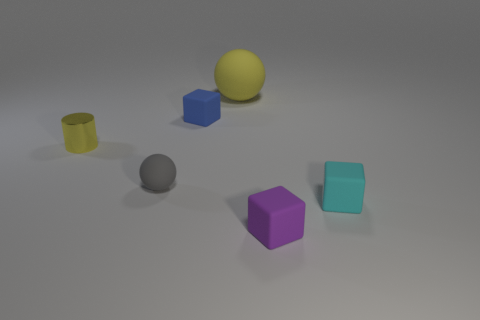What number of brown objects are either tiny cubes or big balls?
Offer a terse response. 0. There is a block on the right side of the matte object that is in front of the small cyan thing; what size is it?
Your answer should be compact. Small. Do the tiny rubber sphere and the small rubber block behind the tiny cylinder have the same color?
Make the answer very short. No. How many other things are there of the same material as the blue thing?
Ensure brevity in your answer.  4. What is the shape of the tiny gray object that is made of the same material as the big object?
Ensure brevity in your answer.  Sphere. Is there anything else that is the same color as the tiny metallic object?
Your answer should be compact. Yes. There is another shiny thing that is the same color as the big thing; what is its size?
Offer a terse response. Small. Is the number of small cyan blocks on the left side of the big yellow sphere greater than the number of yellow rubber objects?
Your answer should be compact. No. There is a blue thing; is its shape the same as the small object that is left of the gray matte sphere?
Offer a terse response. No. How many gray things have the same size as the cyan object?
Provide a short and direct response. 1. 